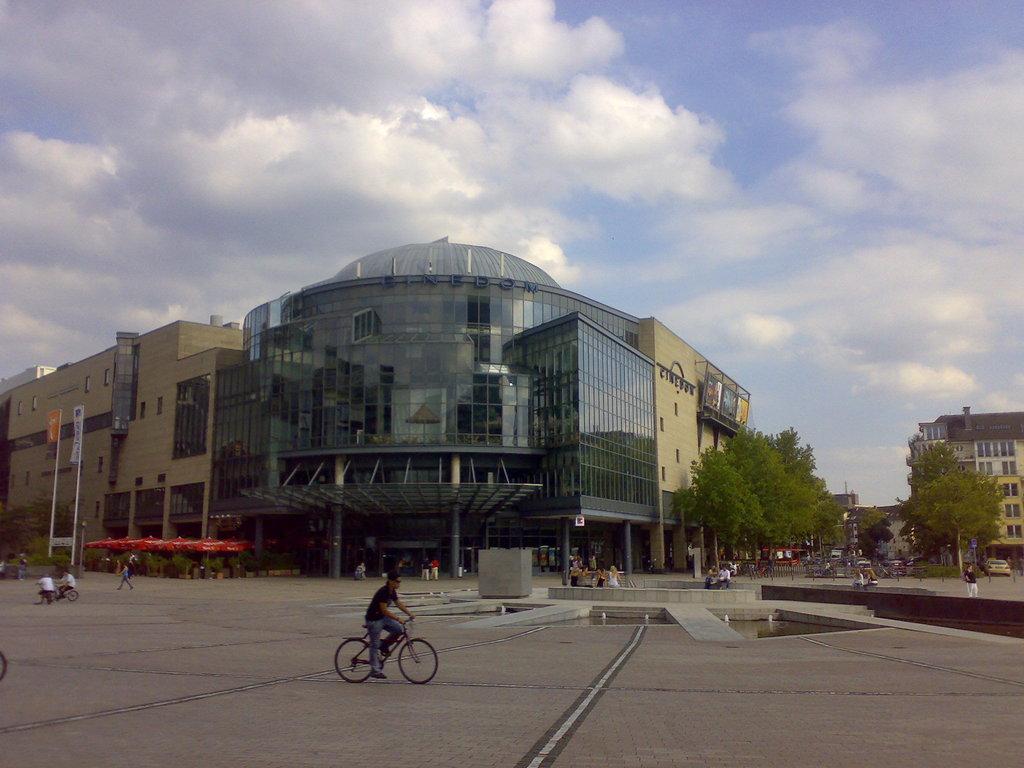Could you give a brief overview of what you see in this image? In this picture we can see some building, in front we can see few people are walking and some people are riding bicycle. 